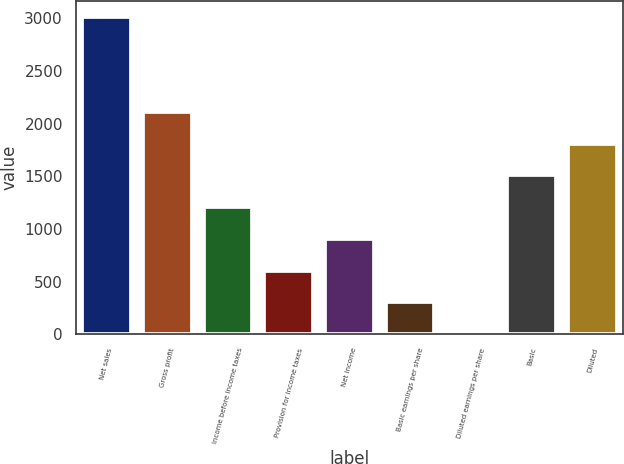Convert chart. <chart><loc_0><loc_0><loc_500><loc_500><bar_chart><fcel>Net sales<fcel>Gross profit<fcel>Income before income taxes<fcel>Provision for income taxes<fcel>Net income<fcel>Basic earnings per share<fcel>Diluted earnings per share<fcel>Basic<fcel>Diluted<nl><fcel>3015<fcel>2110.55<fcel>1206.14<fcel>603.2<fcel>904.67<fcel>301.73<fcel>0.26<fcel>1507.61<fcel>1809.08<nl></chart> 